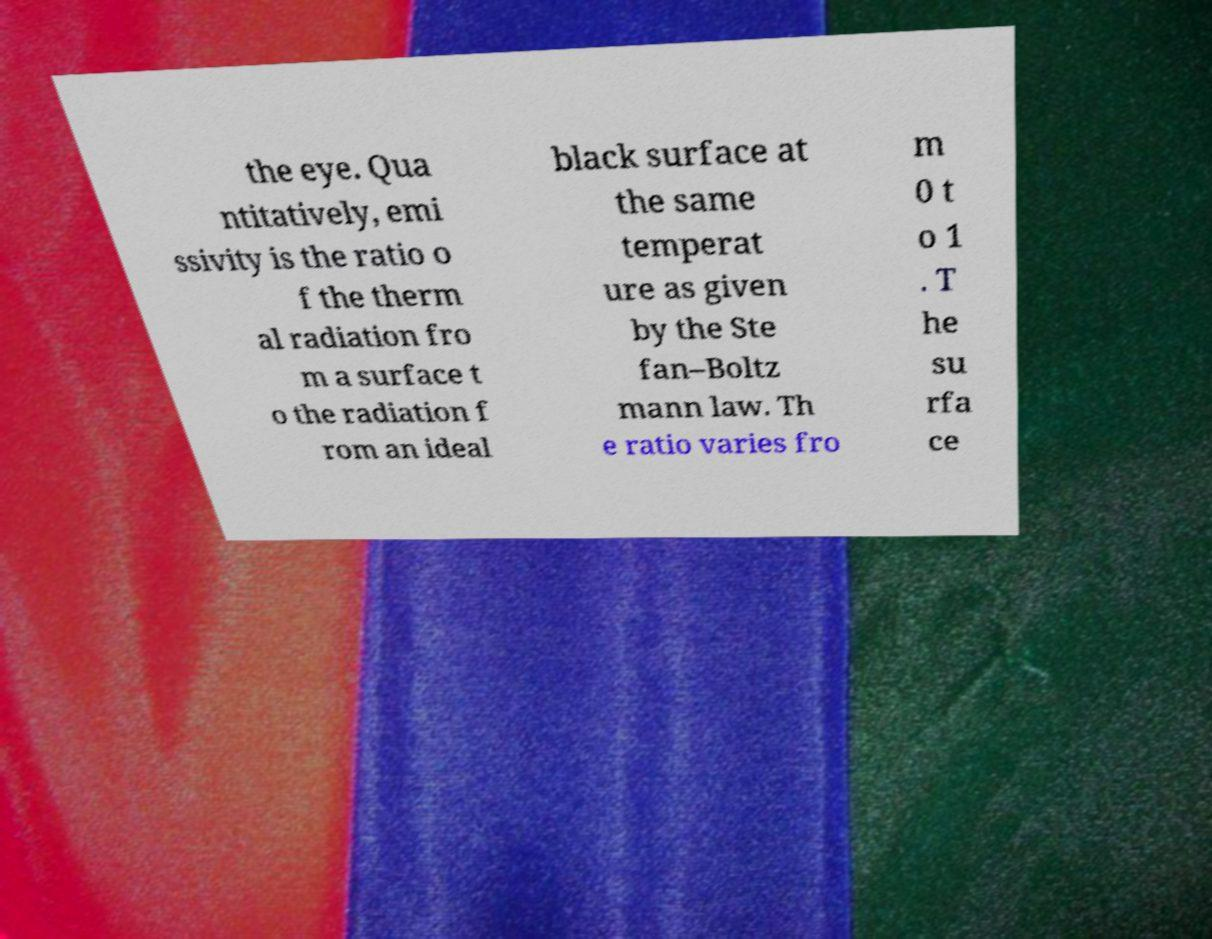I need the written content from this picture converted into text. Can you do that? the eye. Qua ntitatively, emi ssivity is the ratio o f the therm al radiation fro m a surface t o the radiation f rom an ideal black surface at the same temperat ure as given by the Ste fan–Boltz mann law. Th e ratio varies fro m 0 t o 1 . T he su rfa ce 